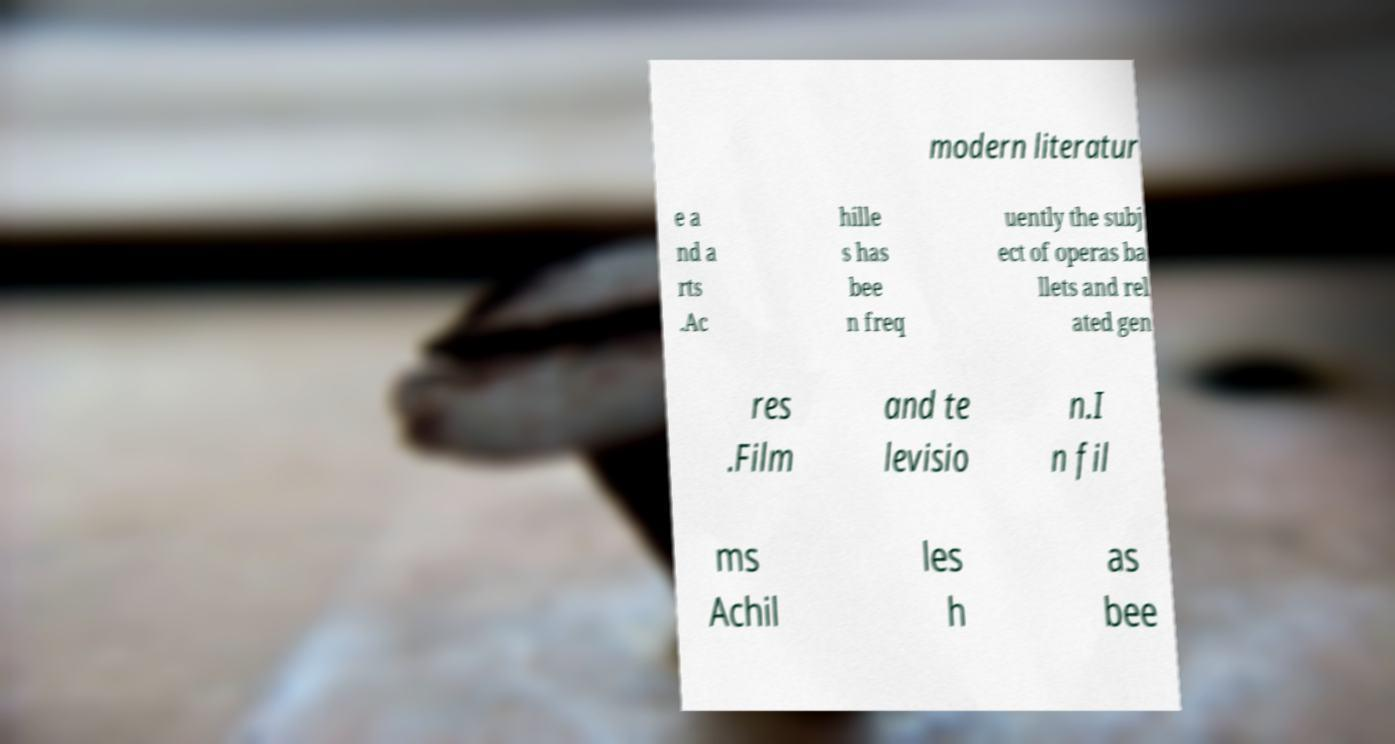Please identify and transcribe the text found in this image. modern literatur e a nd a rts .Ac hille s has bee n freq uently the subj ect of operas ba llets and rel ated gen res .Film and te levisio n.I n fil ms Achil les h as bee 